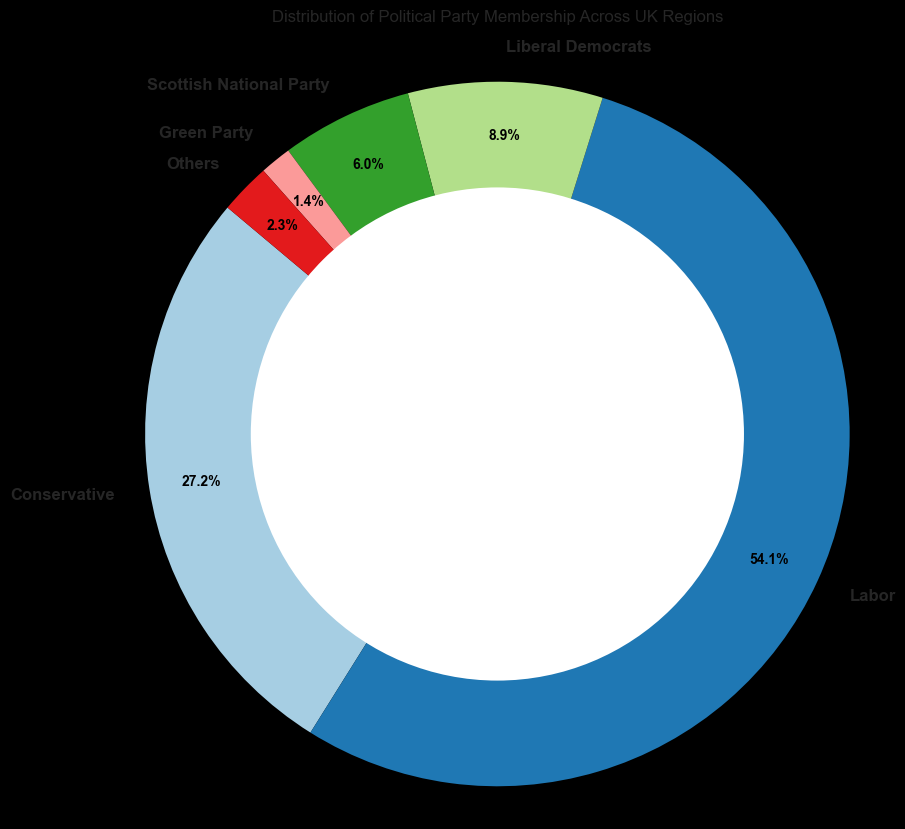Which political party has the highest membership across the UK regions? By observing the ring chart and checking the label with the highest percentage, we can identify which party has the most members.
Answer: Labor Which political party has the lowest membership percentage across the UK regions? By looking at the ring chart for the segment with the smallest percentage label, we can determine the party with the least members.
Answer: Scottish National Party Which two parties combined have a higher membership percentage than the Green Party and the Scottish National Party combined? Compare the combined percentages of each pair of political parties with those of the Green Party and Scottish National Party. Labour and Conservative have higher combined memberships than these two parties together.
Answer: Labour and Conservative Are there any parties with equal membership percentages? If so, which ones? Examine the percentages on the ring chart for any equal values. No parties have equal membership percentages.
Answer: None Which region contributes most to the membership of the Green Party? By analyzing the data, we can identify the specific region that contributes the highest number of members to the Green Party.
Answer: London 